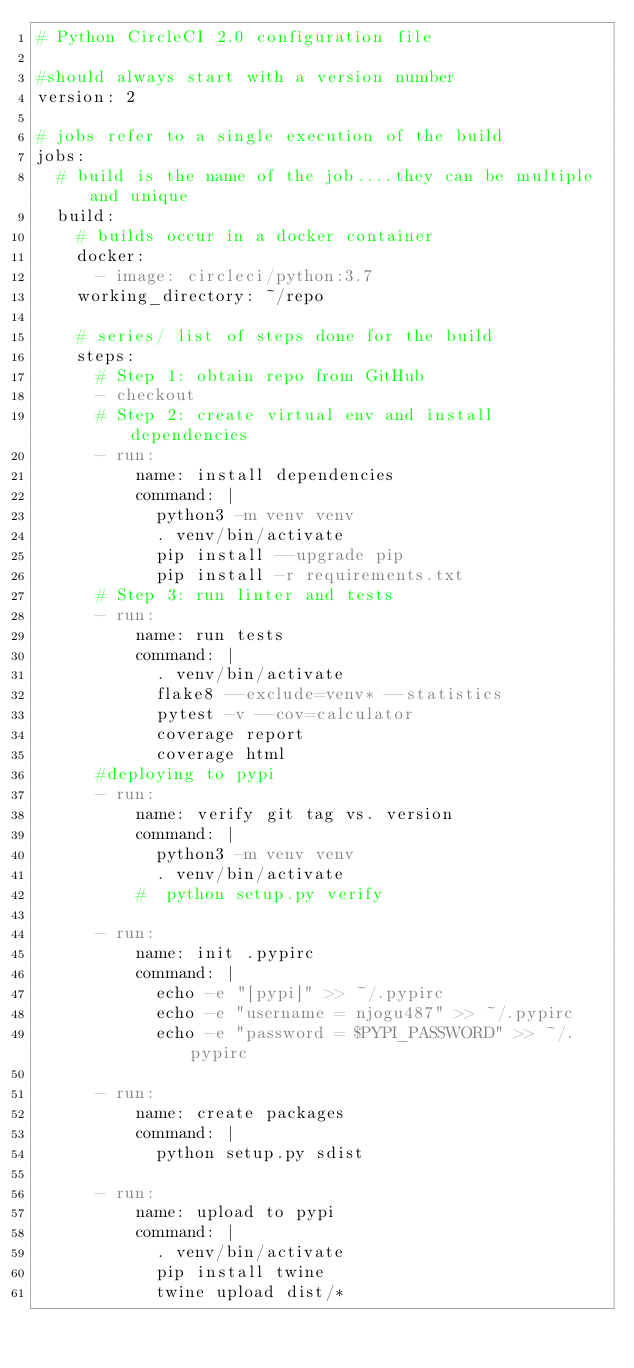Convert code to text. <code><loc_0><loc_0><loc_500><loc_500><_YAML_># Python CircleCI 2.0 configuration file

#should always start with a version number
version: 2

# jobs refer to a single execution of the build
jobs:
  # build is the name of the job....they can be multiple and unique
  build:
    # builds occur in a docker container
    docker:
      - image: circleci/python:3.7
    working_directory: ~/repo

    # series/ list of steps done for the build
    steps:
      # Step 1: obtain repo from GitHub
      - checkout
      # Step 2: create virtual env and install dependencies
      - run:
          name: install dependencies
          command: |
            python3 -m venv venv
            . venv/bin/activate
            pip install --upgrade pip
            pip install -r requirements.txt
      # Step 3: run linter and tests
      - run:
          name: run tests
          command: |
            . venv/bin/activate
            flake8 --exclude=venv* --statistics
            pytest -v --cov=calculator
            coverage report
            coverage html
      #deploying to pypi
      - run:
          name: verify git tag vs. version
          command: |
            python3 -m venv venv
            . venv/bin/activate
          #  python setup.py verify

      - run:
          name: init .pypirc
          command: |
            echo -e "[pypi]" >> ~/.pypirc
            echo -e "username = njogu487" >> ~/.pypirc
            echo -e "password = $PYPI_PASSWORD" >> ~/.pypirc      

      - run:
          name: create packages
          command: |
            python setup.py sdist

      - run:
          name: upload to pypi
          command: |
            . venv/bin/activate
            pip install twine
            twine upload dist/*
            
</code> 